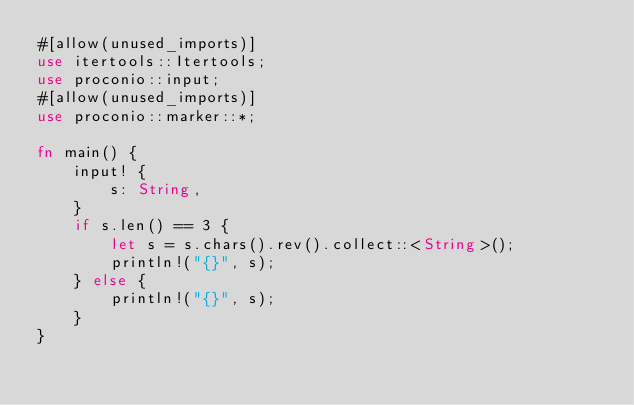Convert code to text. <code><loc_0><loc_0><loc_500><loc_500><_Rust_>#[allow(unused_imports)]
use itertools::Itertools;
use proconio::input;
#[allow(unused_imports)]
use proconio::marker::*;

fn main() {
    input! {
        s: String,
    }
    if s.len() == 3 {
        let s = s.chars().rev().collect::<String>();
        println!("{}", s);
    } else {
        println!("{}", s);
    }
}
</code> 